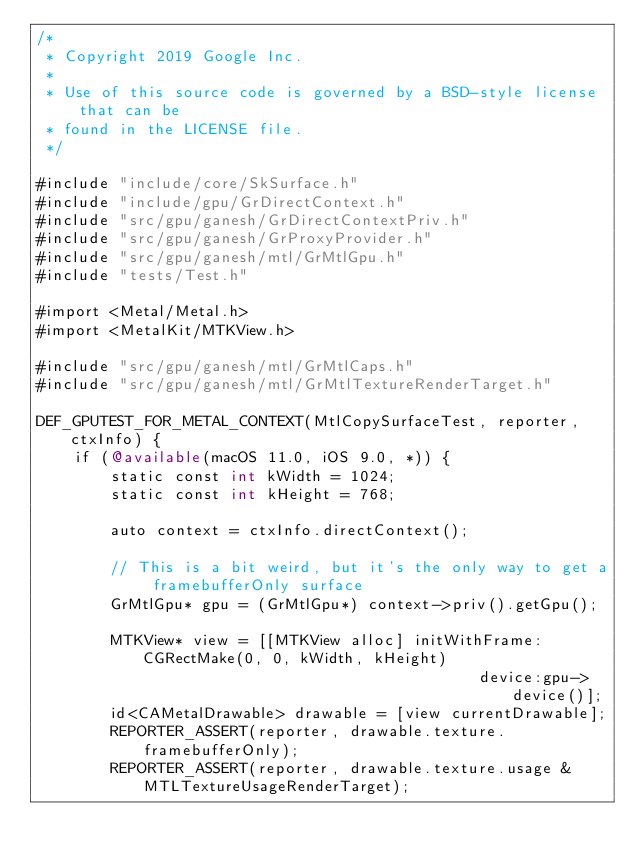<code> <loc_0><loc_0><loc_500><loc_500><_ObjectiveC_>/*
 * Copyright 2019 Google Inc.
 *
 * Use of this source code is governed by a BSD-style license that can be
 * found in the LICENSE file.
 */

#include "include/core/SkSurface.h"
#include "include/gpu/GrDirectContext.h"
#include "src/gpu/ganesh/GrDirectContextPriv.h"
#include "src/gpu/ganesh/GrProxyProvider.h"
#include "src/gpu/ganesh/mtl/GrMtlGpu.h"
#include "tests/Test.h"

#import <Metal/Metal.h>
#import <MetalKit/MTKView.h>

#include "src/gpu/ganesh/mtl/GrMtlCaps.h"
#include "src/gpu/ganesh/mtl/GrMtlTextureRenderTarget.h"

DEF_GPUTEST_FOR_METAL_CONTEXT(MtlCopySurfaceTest, reporter, ctxInfo) {
    if (@available(macOS 11.0, iOS 9.0, *)) {
        static const int kWidth = 1024;
        static const int kHeight = 768;

        auto context = ctxInfo.directContext();

        // This is a bit weird, but it's the only way to get a framebufferOnly surface
        GrMtlGpu* gpu = (GrMtlGpu*) context->priv().getGpu();

        MTKView* view = [[MTKView alloc] initWithFrame:CGRectMake(0, 0, kWidth, kHeight)
                                                device:gpu->device()];
        id<CAMetalDrawable> drawable = [view currentDrawable];
        REPORTER_ASSERT(reporter, drawable.texture.framebufferOnly);
        REPORTER_ASSERT(reporter, drawable.texture.usage & MTLTextureUsageRenderTarget);
</code> 